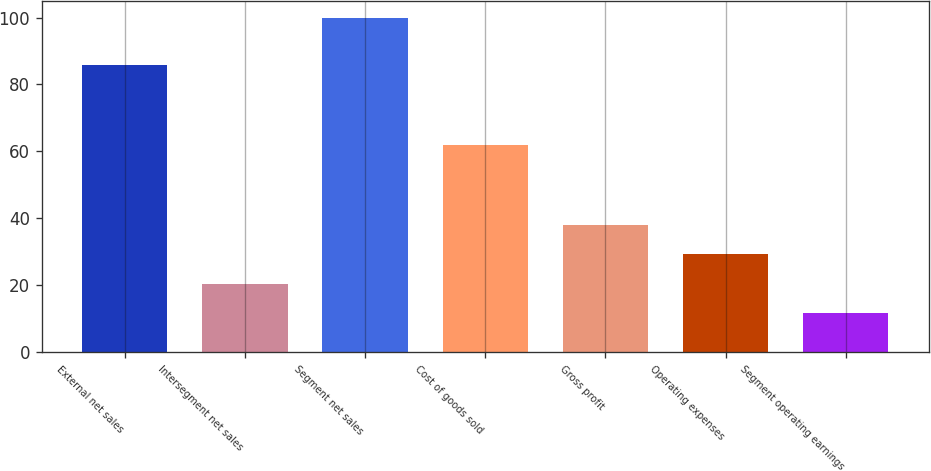Convert chart. <chart><loc_0><loc_0><loc_500><loc_500><bar_chart><fcel>External net sales<fcel>Intersegment net sales<fcel>Segment net sales<fcel>Cost of goods sold<fcel>Gross profit<fcel>Operating expenses<fcel>Segment operating earnings<nl><fcel>85.9<fcel>20.44<fcel>100<fcel>61.9<fcel>38.12<fcel>29.28<fcel>11.6<nl></chart> 